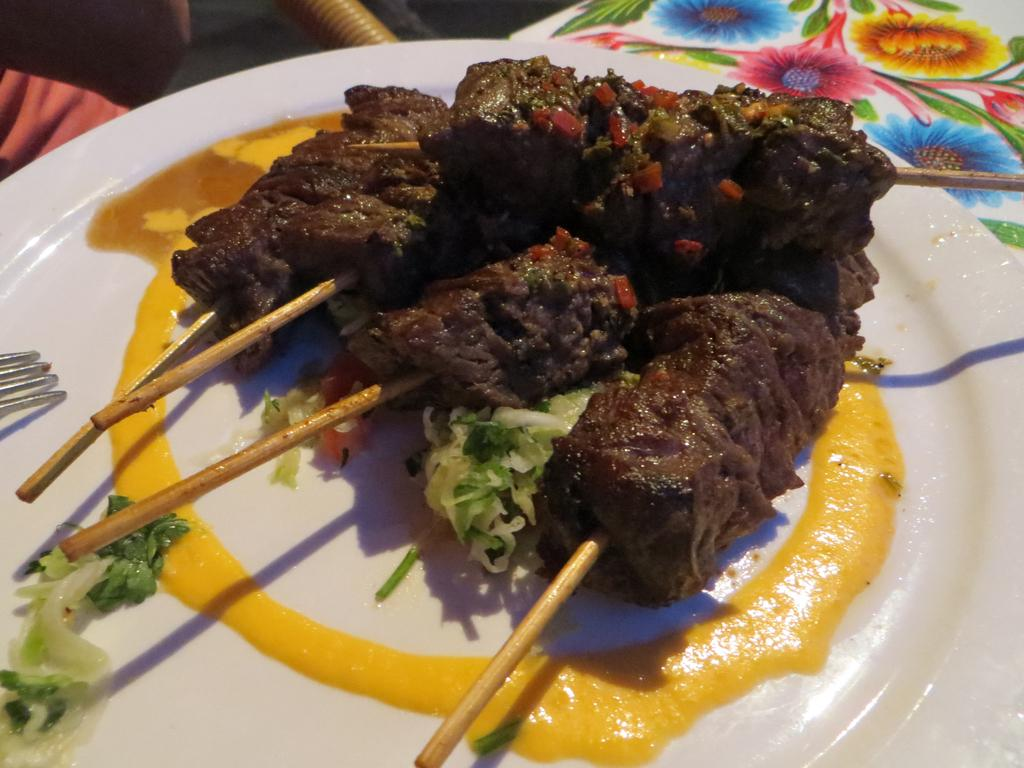What is on the plate that is visible in the image? There are food items on a plate in the image. Where is the plate located in the image? The plate is placed on a table in the image. Can you describe the table's surface in the image? The table has a floral print on its surface. What type of soup is being served in the image? There is no soup present in the image; the food items on the plate are not specified. 